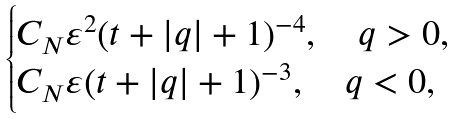<formula> <loc_0><loc_0><loc_500><loc_500>\begin{cases} C _ { N } \varepsilon ^ { 2 } ( t + | q | + 1 ) ^ { - 4 } , \quad q > 0 , \\ C _ { N } \varepsilon ( t + | q | + 1 ) ^ { - 3 } , \quad q < 0 , \end{cases}</formula> 